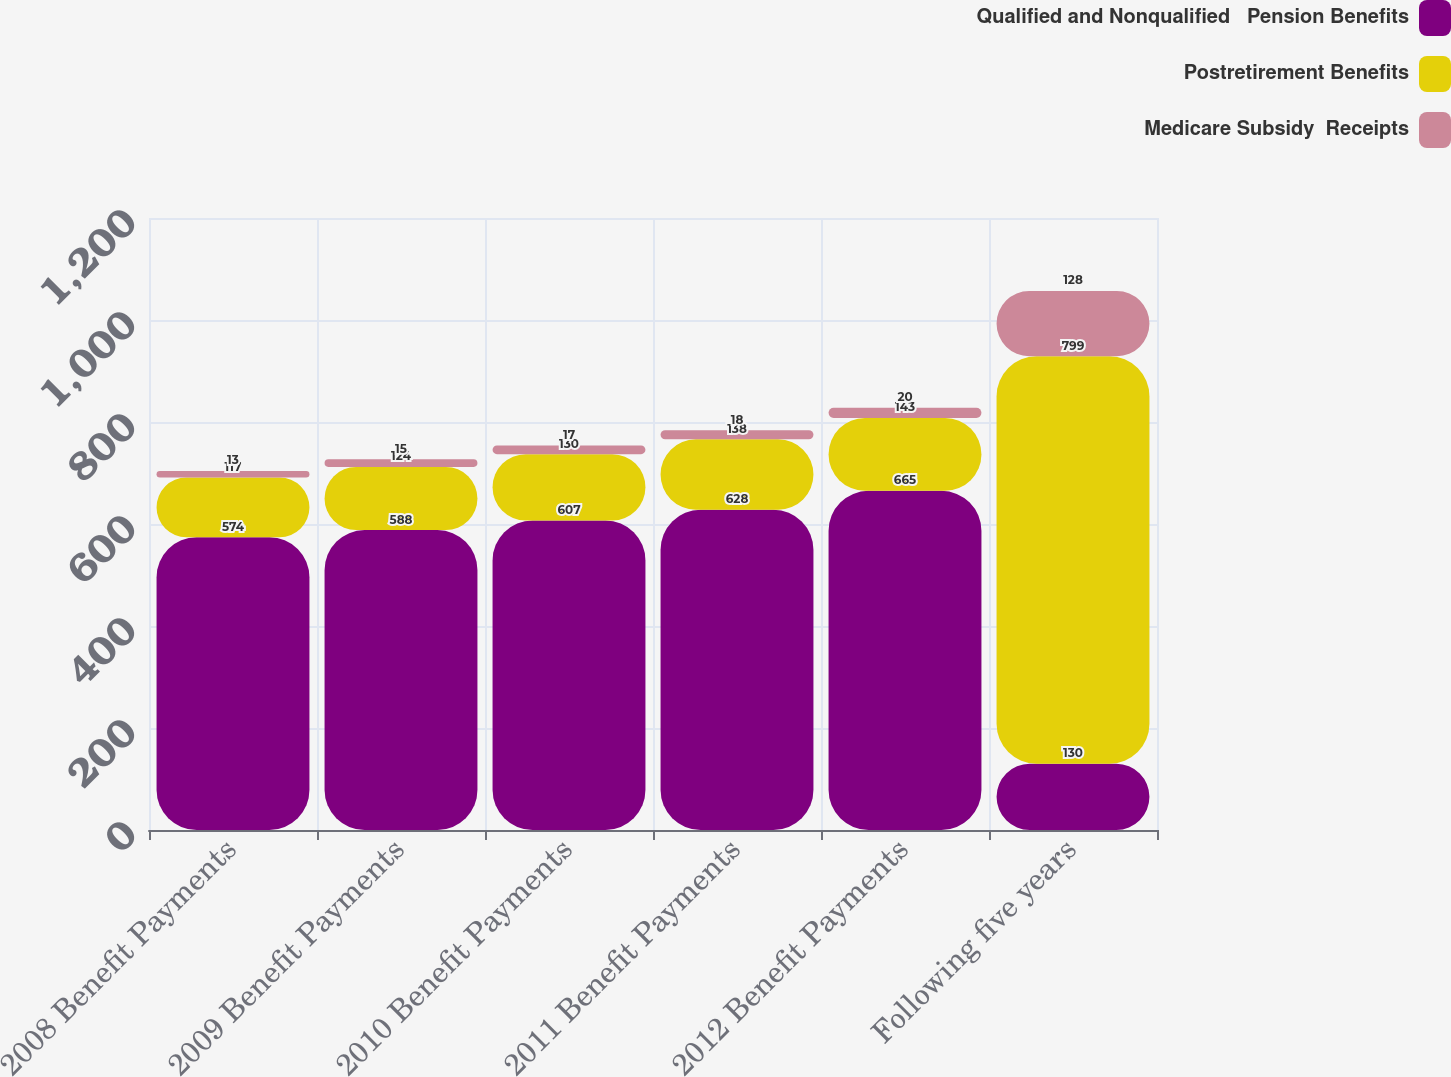Convert chart to OTSL. <chart><loc_0><loc_0><loc_500><loc_500><stacked_bar_chart><ecel><fcel>2008 Benefit Payments<fcel>2009 Benefit Payments<fcel>2010 Benefit Payments<fcel>2011 Benefit Payments<fcel>2012 Benefit Payments<fcel>Following five years<nl><fcel>Qualified and Nonqualified   Pension Benefits<fcel>574<fcel>588<fcel>607<fcel>628<fcel>665<fcel>130<nl><fcel>Postretirement Benefits<fcel>117<fcel>124<fcel>130<fcel>138<fcel>143<fcel>799<nl><fcel>Medicare Subsidy  Receipts<fcel>13<fcel>15<fcel>17<fcel>18<fcel>20<fcel>128<nl></chart> 